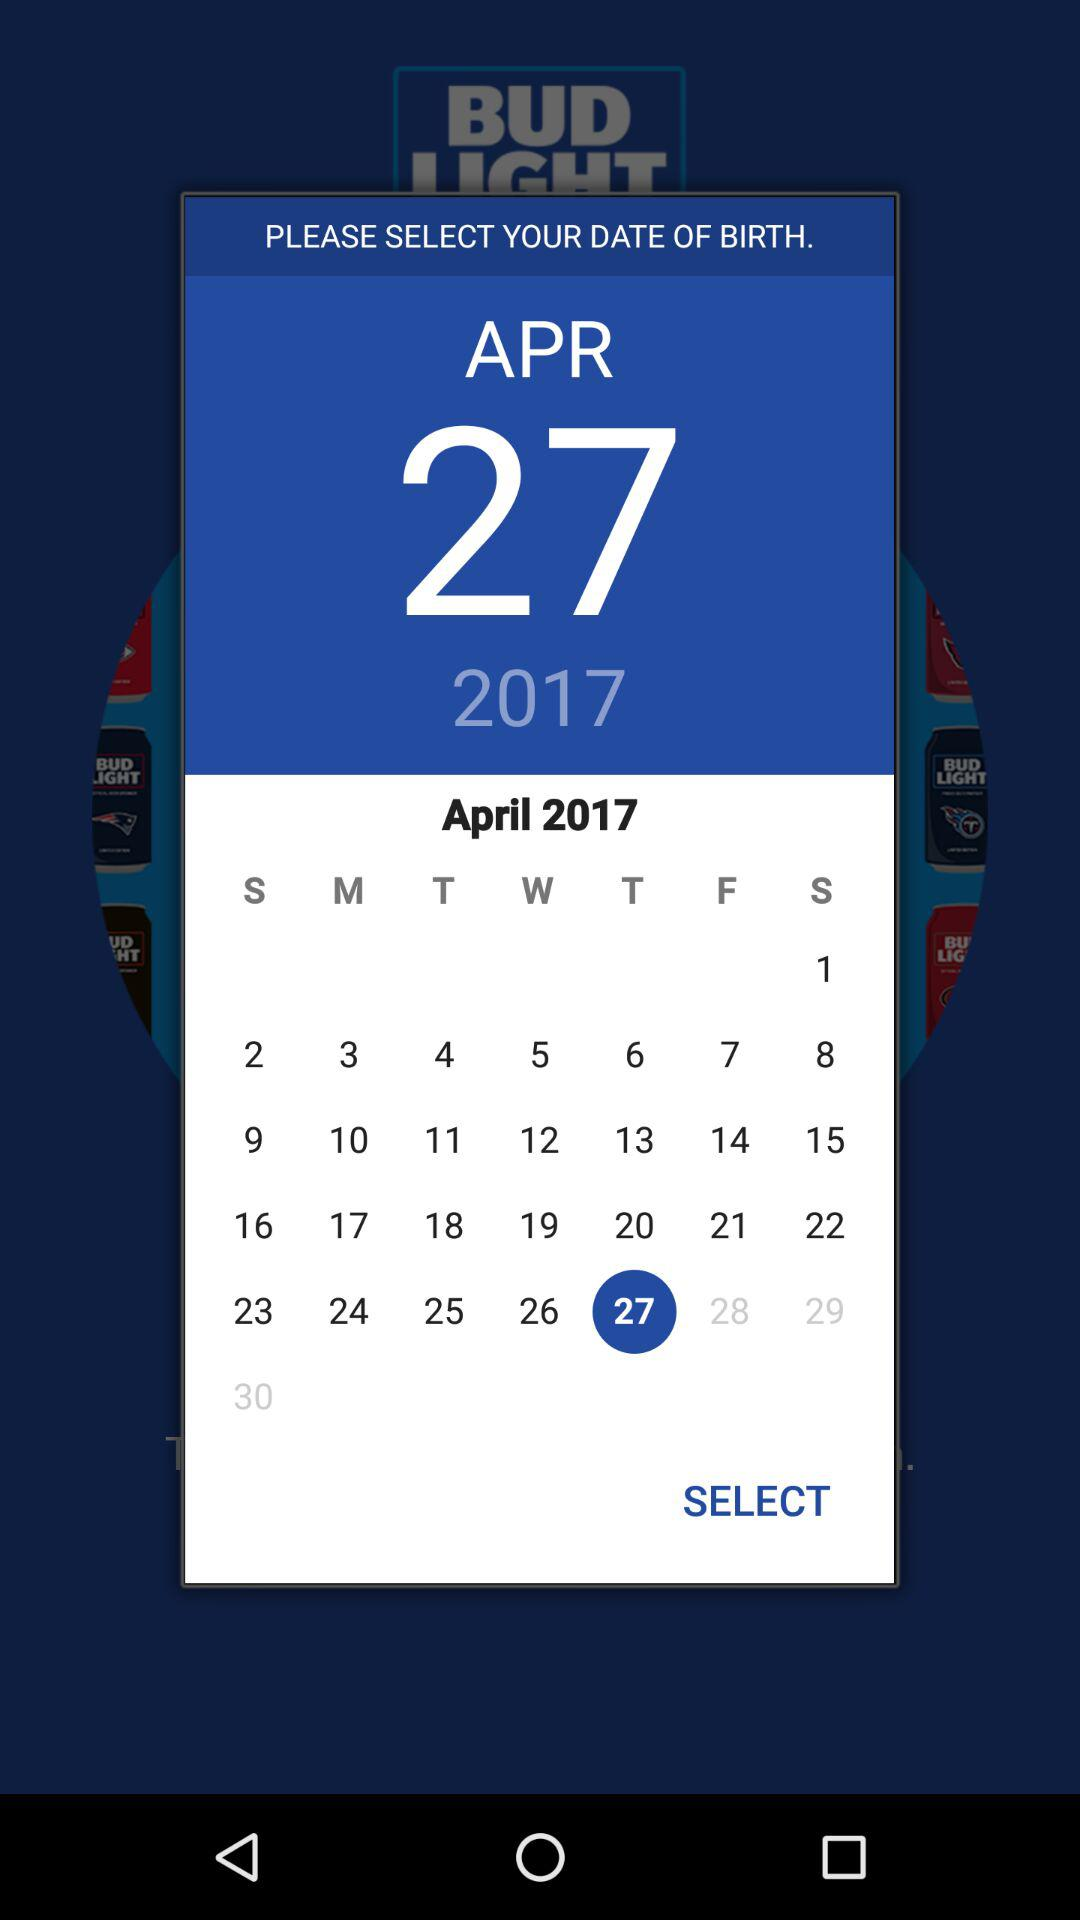What is the day on the selected date? The day on the selected date is Thursday. 